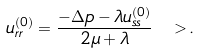<formula> <loc_0><loc_0><loc_500><loc_500>u _ { r r } ^ { ( 0 ) } = \frac { - \Delta p - \lambda u _ { s s } ^ { ( 0 ) } } { 2 \mu + \lambda } \ > .</formula> 